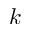Convert formula to latex. <formula><loc_0><loc_0><loc_500><loc_500>k</formula> 